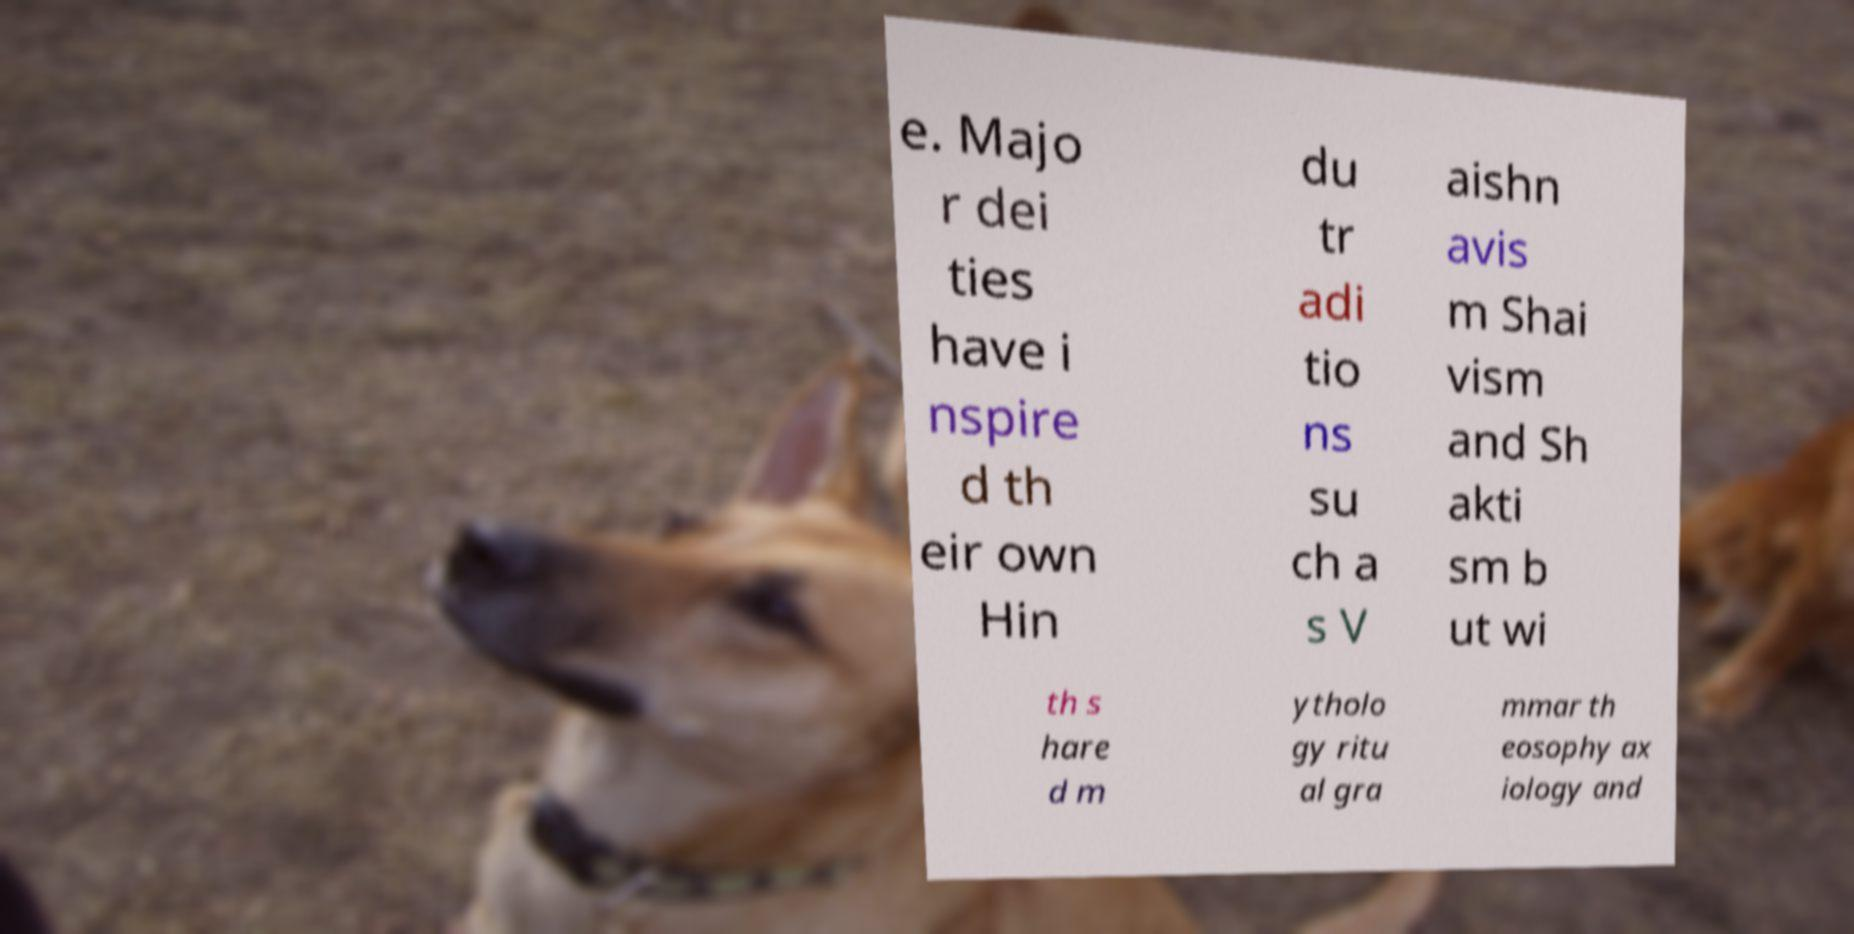There's text embedded in this image that I need extracted. Can you transcribe it verbatim? e. Majo r dei ties have i nspire d th eir own Hin du tr adi tio ns su ch a s V aishn avis m Shai vism and Sh akti sm b ut wi th s hare d m ytholo gy ritu al gra mmar th eosophy ax iology and 